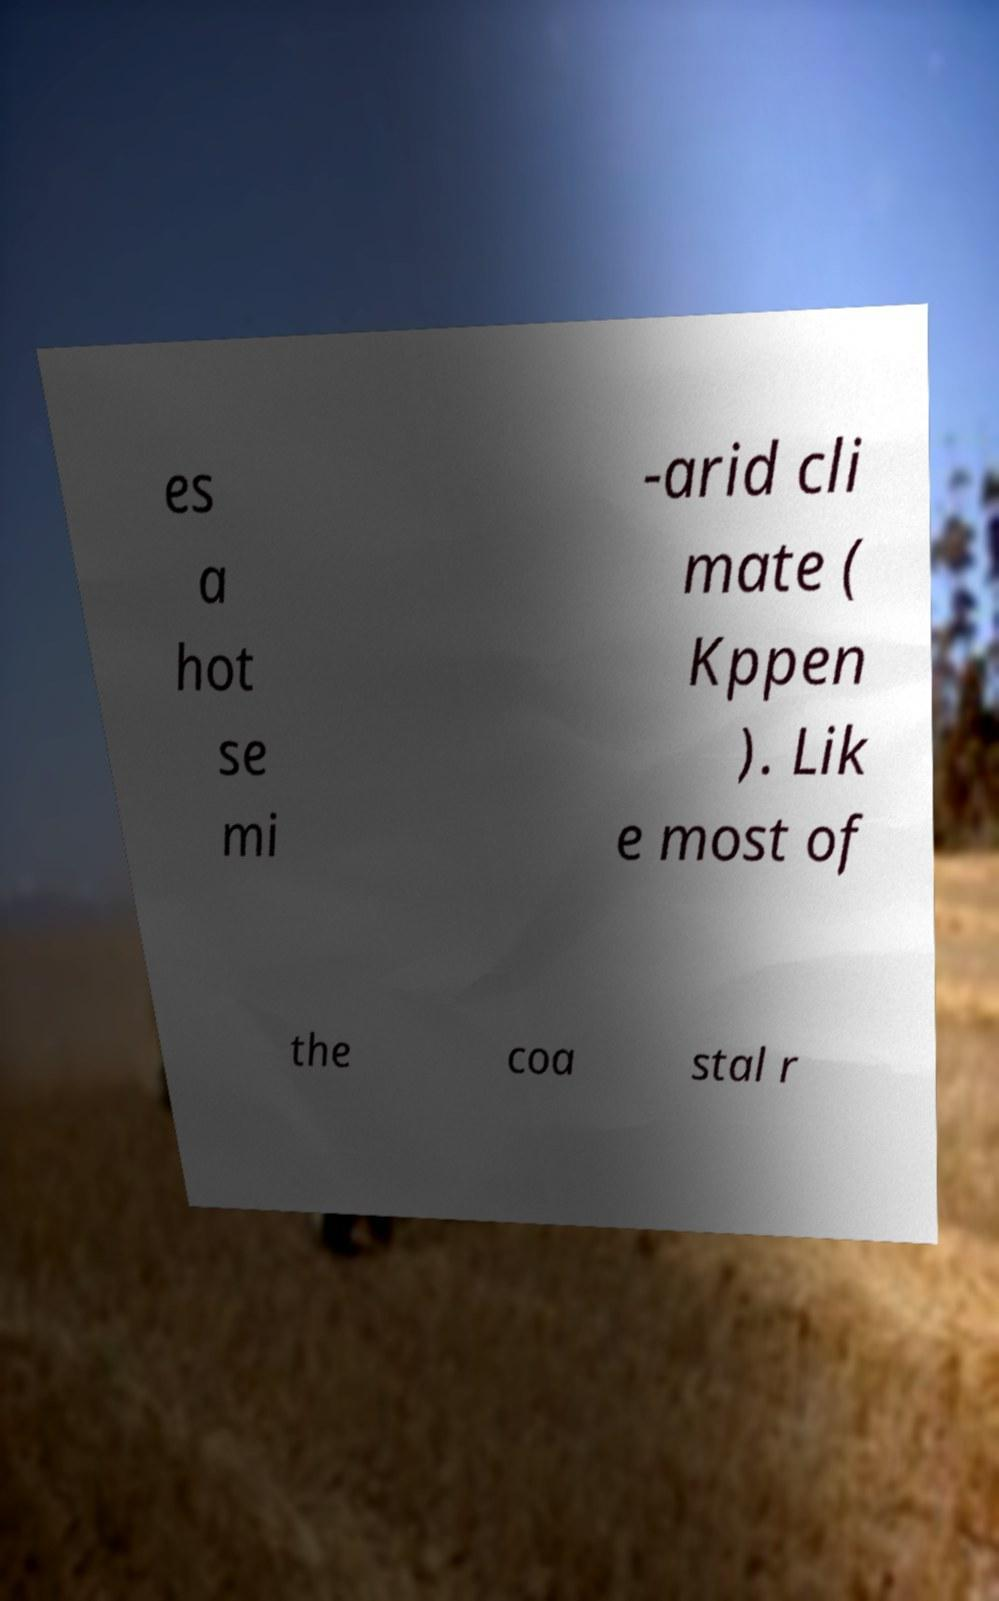There's text embedded in this image that I need extracted. Can you transcribe it verbatim? es a hot se mi -arid cli mate ( Kppen ). Lik e most of the coa stal r 